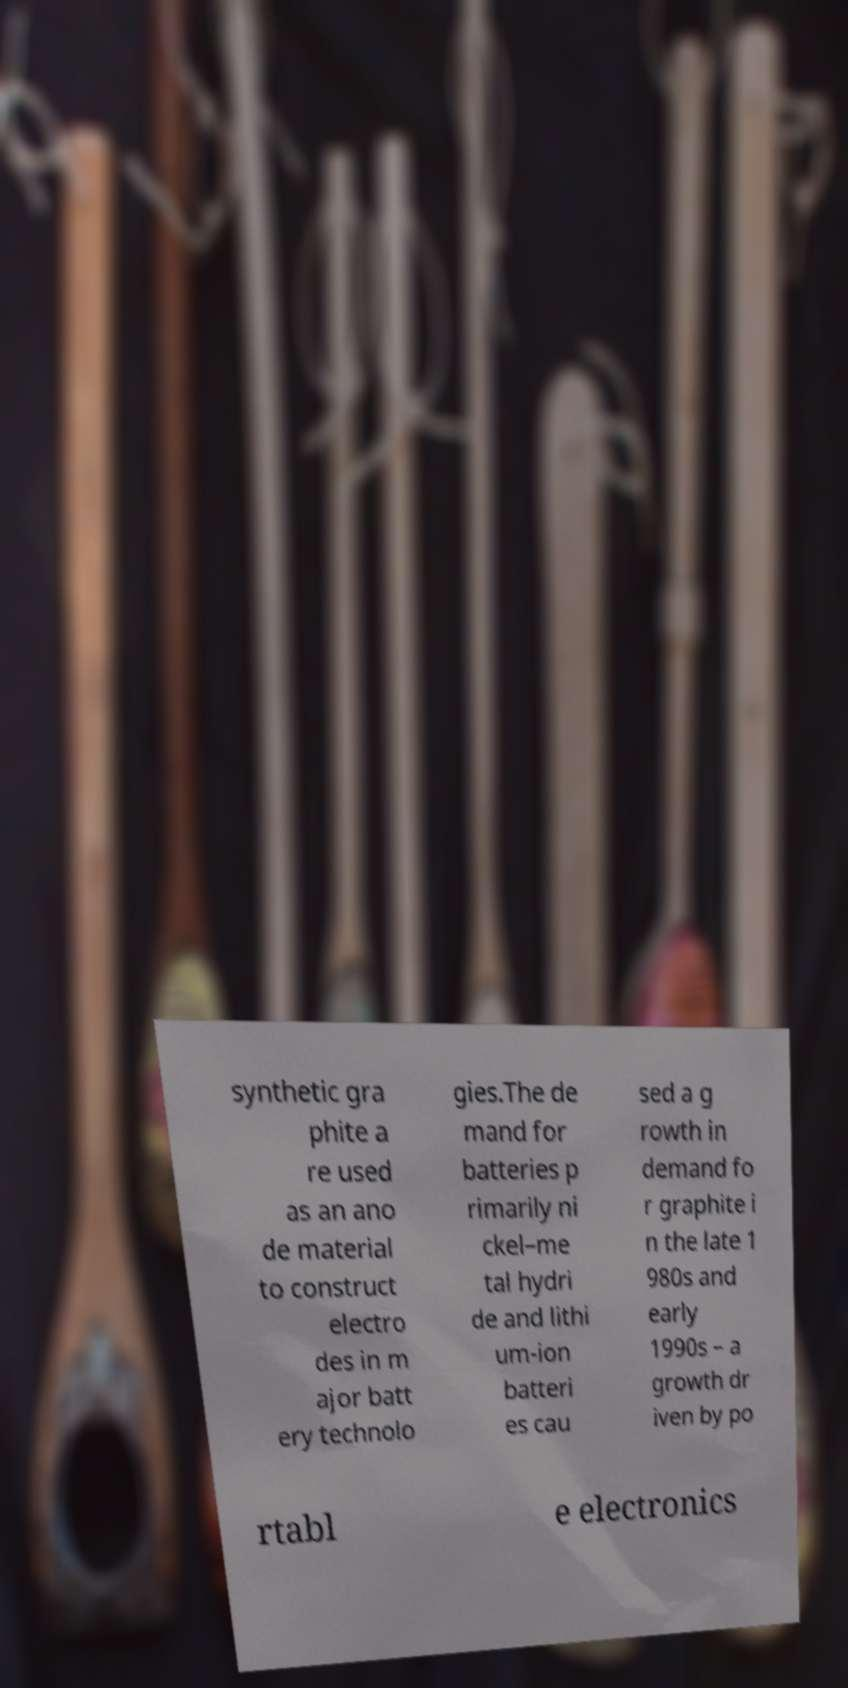Could you assist in decoding the text presented in this image and type it out clearly? synthetic gra phite a re used as an ano de material to construct electro des in m ajor batt ery technolo gies.The de mand for batteries p rimarily ni ckel–me tal hydri de and lithi um-ion batteri es cau sed a g rowth in demand fo r graphite i n the late 1 980s and early 1990s – a growth dr iven by po rtabl e electronics 